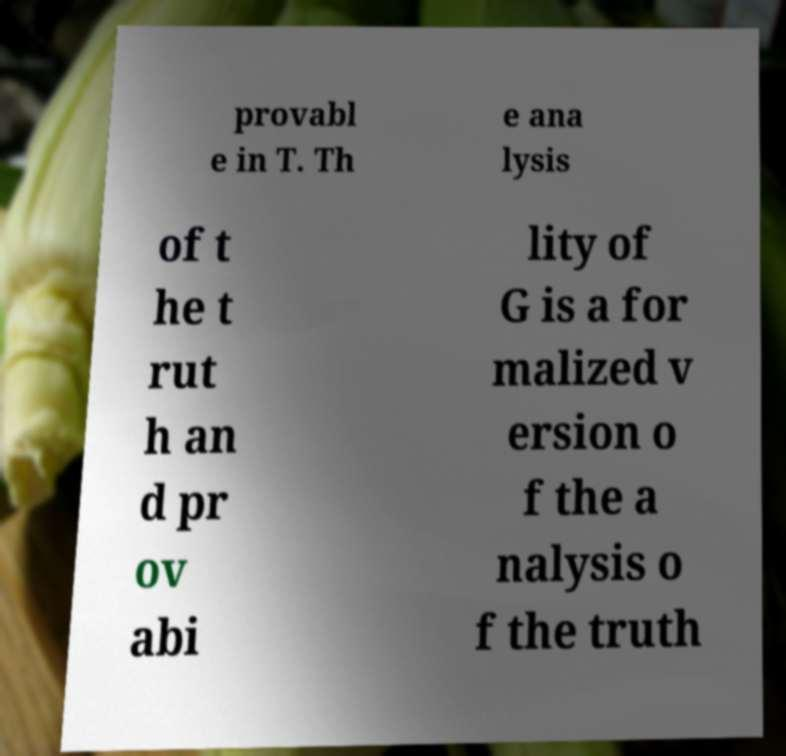Can you read and provide the text displayed in the image?This photo seems to have some interesting text. Can you extract and type it out for me? provabl e in T. Th e ana lysis of t he t rut h an d pr ov abi lity of G is a for malized v ersion o f the a nalysis o f the truth 